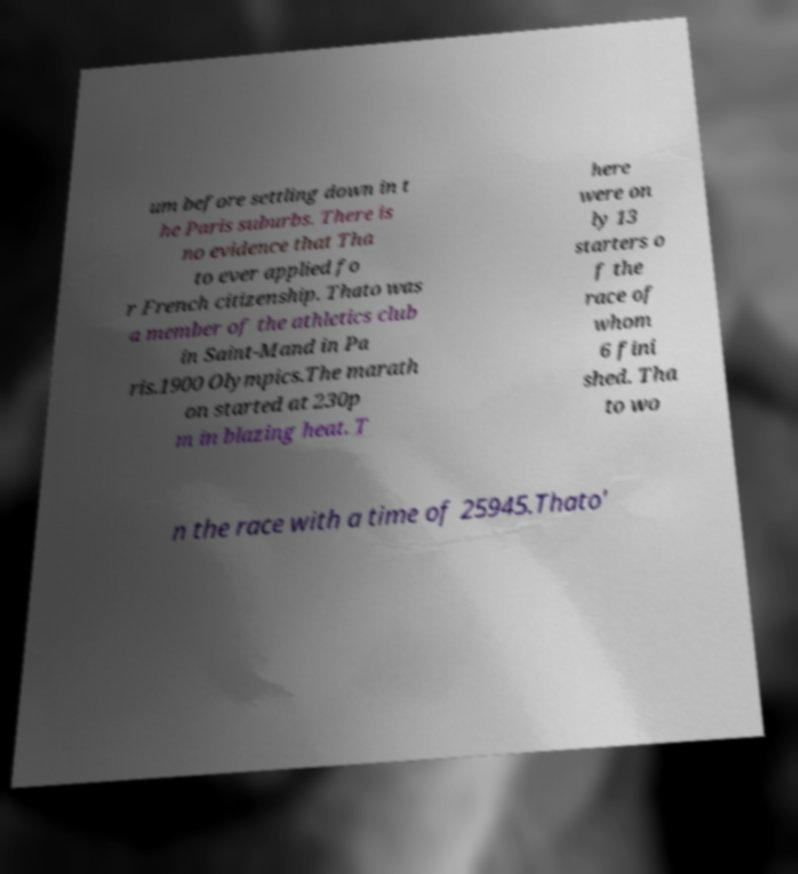I need the written content from this picture converted into text. Can you do that? um before settling down in t he Paris suburbs. There is no evidence that Tha to ever applied fo r French citizenship. Thato was a member of the athletics club in Saint-Mand in Pa ris.1900 Olympics.The marath on started at 230p m in blazing heat. T here were on ly 13 starters o f the race of whom 6 fini shed. Tha to wo n the race with a time of 25945.Thato' 